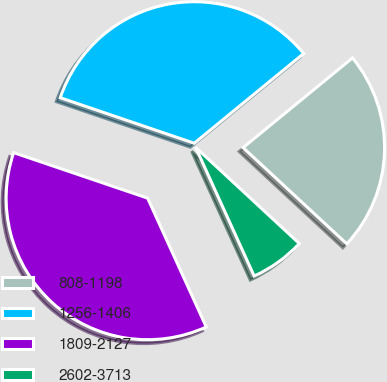<chart> <loc_0><loc_0><loc_500><loc_500><pie_chart><fcel>808-1198<fcel>1256-1406<fcel>1809-2127<fcel>2602-3713<nl><fcel>22.83%<fcel>33.86%<fcel>37.01%<fcel>6.3%<nl></chart> 